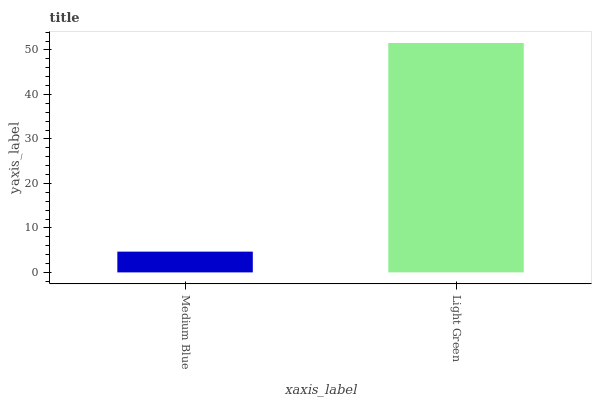Is Medium Blue the minimum?
Answer yes or no. Yes. Is Light Green the maximum?
Answer yes or no. Yes. Is Light Green the minimum?
Answer yes or no. No. Is Light Green greater than Medium Blue?
Answer yes or no. Yes. Is Medium Blue less than Light Green?
Answer yes or no. Yes. Is Medium Blue greater than Light Green?
Answer yes or no. No. Is Light Green less than Medium Blue?
Answer yes or no. No. Is Light Green the high median?
Answer yes or no. Yes. Is Medium Blue the low median?
Answer yes or no. Yes. Is Medium Blue the high median?
Answer yes or no. No. Is Light Green the low median?
Answer yes or no. No. 